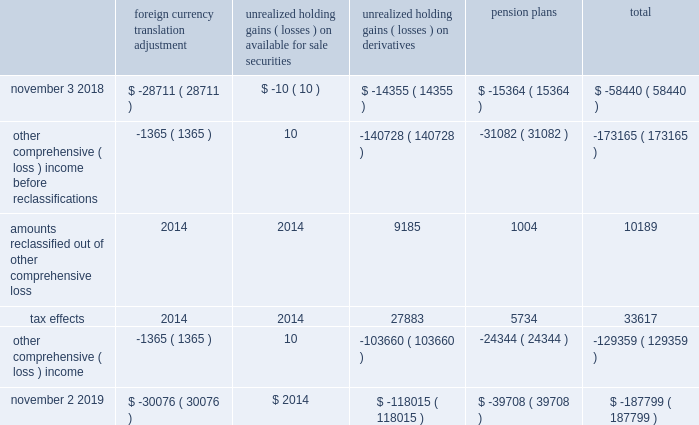Expected durations of less than one year .
The company generally offers a twelve-month warranty for its products .
The company 2019s warranty policy provides for replacement of defective products .
Specific accruals are recorded forff known product warranty issues .
Transaction price : the transaction price reflects the company 2019s expectations about the consideration it will be entitled to receive from the customer and may include fixed or variable amounts .
Fixed consideration primarily includes sales to direct customers and sales to distributors in which both the sale to the distributor and the sale to the end customer occur within the same reporting period .
Variable consideration includes sales in which the amount of consideration that the company will receive is unknown as of the end of a reporting period .
Such consideration primarily includes credits issued to the distributor due to price protection and sales made to distributors under agreements that allow certain rights of return , referred to as stock rotation .
Price protection represents price discounts granted to certain distributors to allow the distributor to earn an appropriate margin on sales negotiated with certain customers and in the event of a price decrease subsequent to the date the product was shipped and billed to the distributor .
Stock rotation allows distributors limited levels of returns in order to reduce the amounts of slow-moving , discontinued or obsolete product from their inventory .
A liability for distributor credits covering variable consideration is made based on the company's estimate of historical experience rates as well as considering economic conditions and contractual terms .
To date , actual distributor claims activity has been materially consistent with the provisions the company has made based on its historical estimates .
For the years ended november 2 , 2019 and november 3 , 2018 , sales to distributors were $ 3.4 billion in both periods , net of variable consideration for which the liability balances as of november 2 , 2019 and november 3 , 2018 were $ 227.0 million and $ 144.9 million , respectively .
Contract balances : accounts receivable represents the company 2019s unconditional right to receive consideration from its customers .
Payments are typically due within 30 to 45 days of invoicing and do not include a significant financing component .
To date , there have been no material impairment losses on accounts receivable .
There were no material contract assets or contract liabilities recorded on the consolidated balance sheets in any of the periods presented .
The company generally warrants that products will meet their published specifications and that the company will repair or replace defective products for twelve-months from the date title passes to the customer .
Specific accruals are recorded for known product warranty issues .
Product warranty expenses during fiscal 2019 , fiscal 2018 and fiscal 2017 were not material .
Accumulated other compcc rehensive ( loss ) income accumulated other comprehensive ( loss ) income ( aoci ) includes certain transactions that have generally been reported in the consolidated statement of shareholders 2019 equity .
The components of aoci at november 2 , 2019 and november 3 , 2018 consisted of the following , net of tax : foreign currency translation adjustment unrealized holding gains ( losses ) on available for sale securities unrealized holding ( losses ) on derivatives pension plans total .
November 2 , 2019 $ ( 30076 ) $ 2014 $ ( 118015 ) $ ( 39708 ) $ ( 187799 ) ( ) ( ) ( ) ( ) ( ) ( ) ( ) ( ) analog devices , inc .
Notes to consolidated financial statements 2014 ( continued ) .
What is the percentage change in the liability balance from 2018 to 2019? 
Computations: ((227.0 - 144.9) / 144.9)
Answer: 0.5666. 